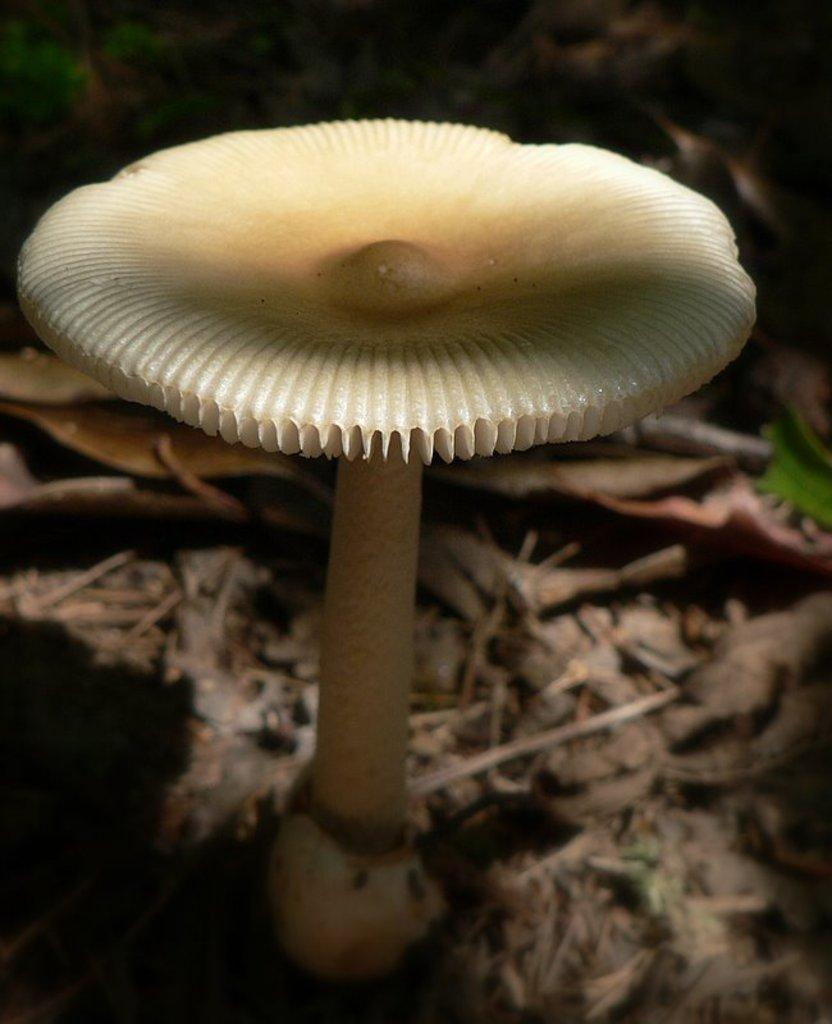What type of plant is depicted in the image? The plant resembles a mushroom. Can you describe the appearance of the plant? The plant has a mushroom-like shape. What else can be seen at the bottom of the image? There are dried leaves at the bottom of the image. How many boats can be seen in the harbor in the image? There is no harbor or boats present in the image; it features a plant that resembles a mushroom and dried leaves. 